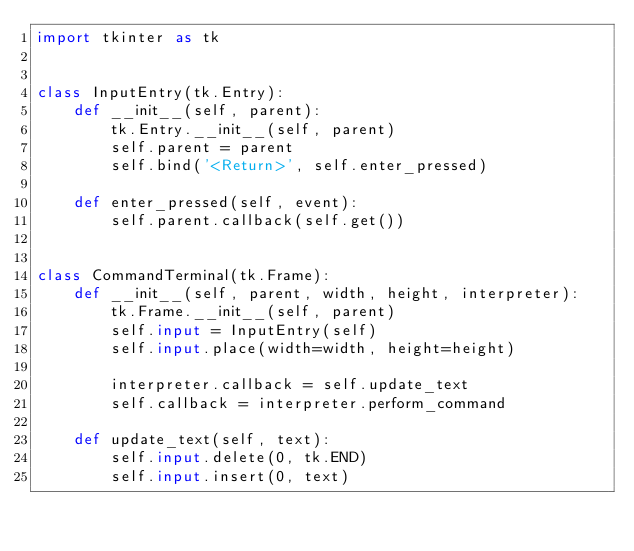<code> <loc_0><loc_0><loc_500><loc_500><_Python_>import tkinter as tk


class InputEntry(tk.Entry):
    def __init__(self, parent):
        tk.Entry.__init__(self, parent)
        self.parent = parent
        self.bind('<Return>', self.enter_pressed)

    def enter_pressed(self, event):
        self.parent.callback(self.get())


class CommandTerminal(tk.Frame):
    def __init__(self, parent, width, height, interpreter):
        tk.Frame.__init__(self, parent)
        self.input = InputEntry(self)
        self.input.place(width=width, height=height)

        interpreter.callback = self.update_text
        self.callback = interpreter.perform_command

    def update_text(self, text):
        self.input.delete(0, tk.END)
        self.input.insert(0, text)
</code> 